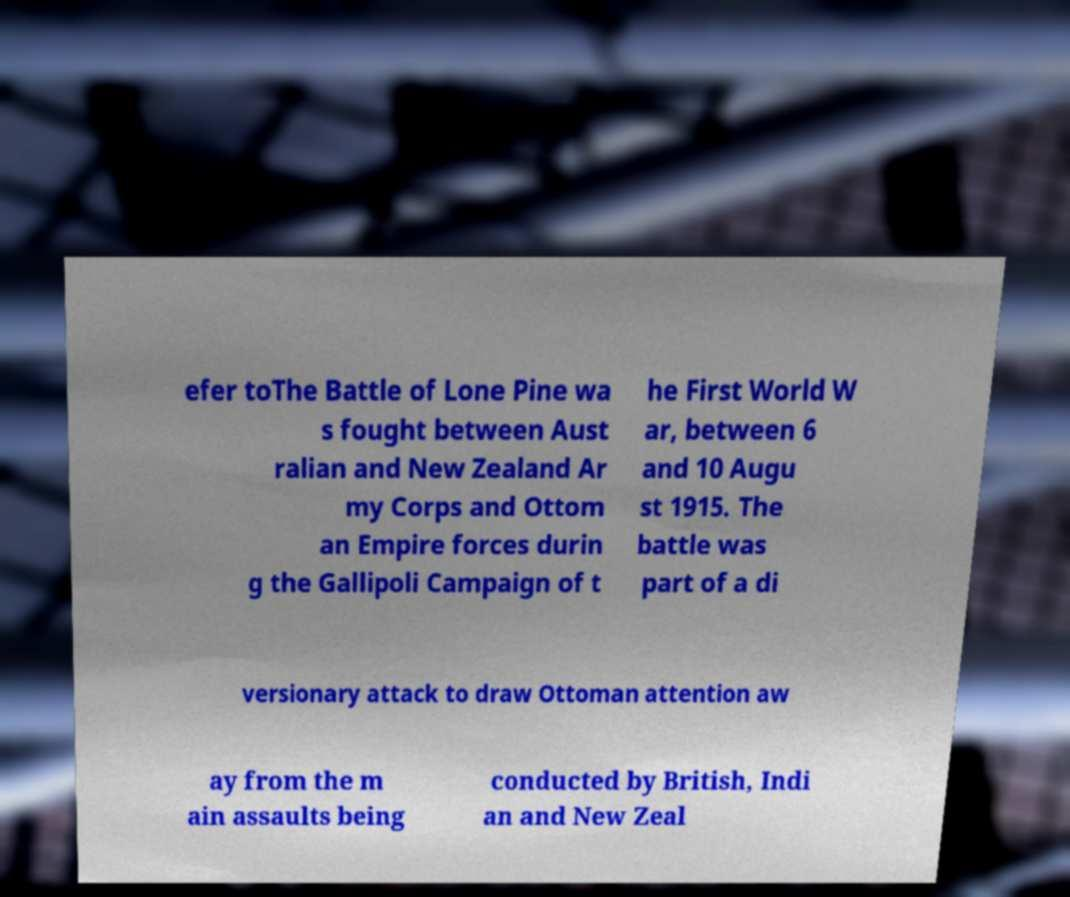Can you accurately transcribe the text from the provided image for me? efer toThe Battle of Lone Pine wa s fought between Aust ralian and New Zealand Ar my Corps and Ottom an Empire forces durin g the Gallipoli Campaign of t he First World W ar, between 6 and 10 Augu st 1915. The battle was part of a di versionary attack to draw Ottoman attention aw ay from the m ain assaults being conducted by British, Indi an and New Zeal 